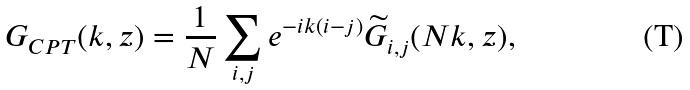<formula> <loc_0><loc_0><loc_500><loc_500>G _ { C P T } ( k , z ) = \frac { 1 } { N } \sum _ { i , j } e ^ { - i k ( i - j ) } \widetilde { G } _ { i , j } ( N k , z ) ,</formula> 